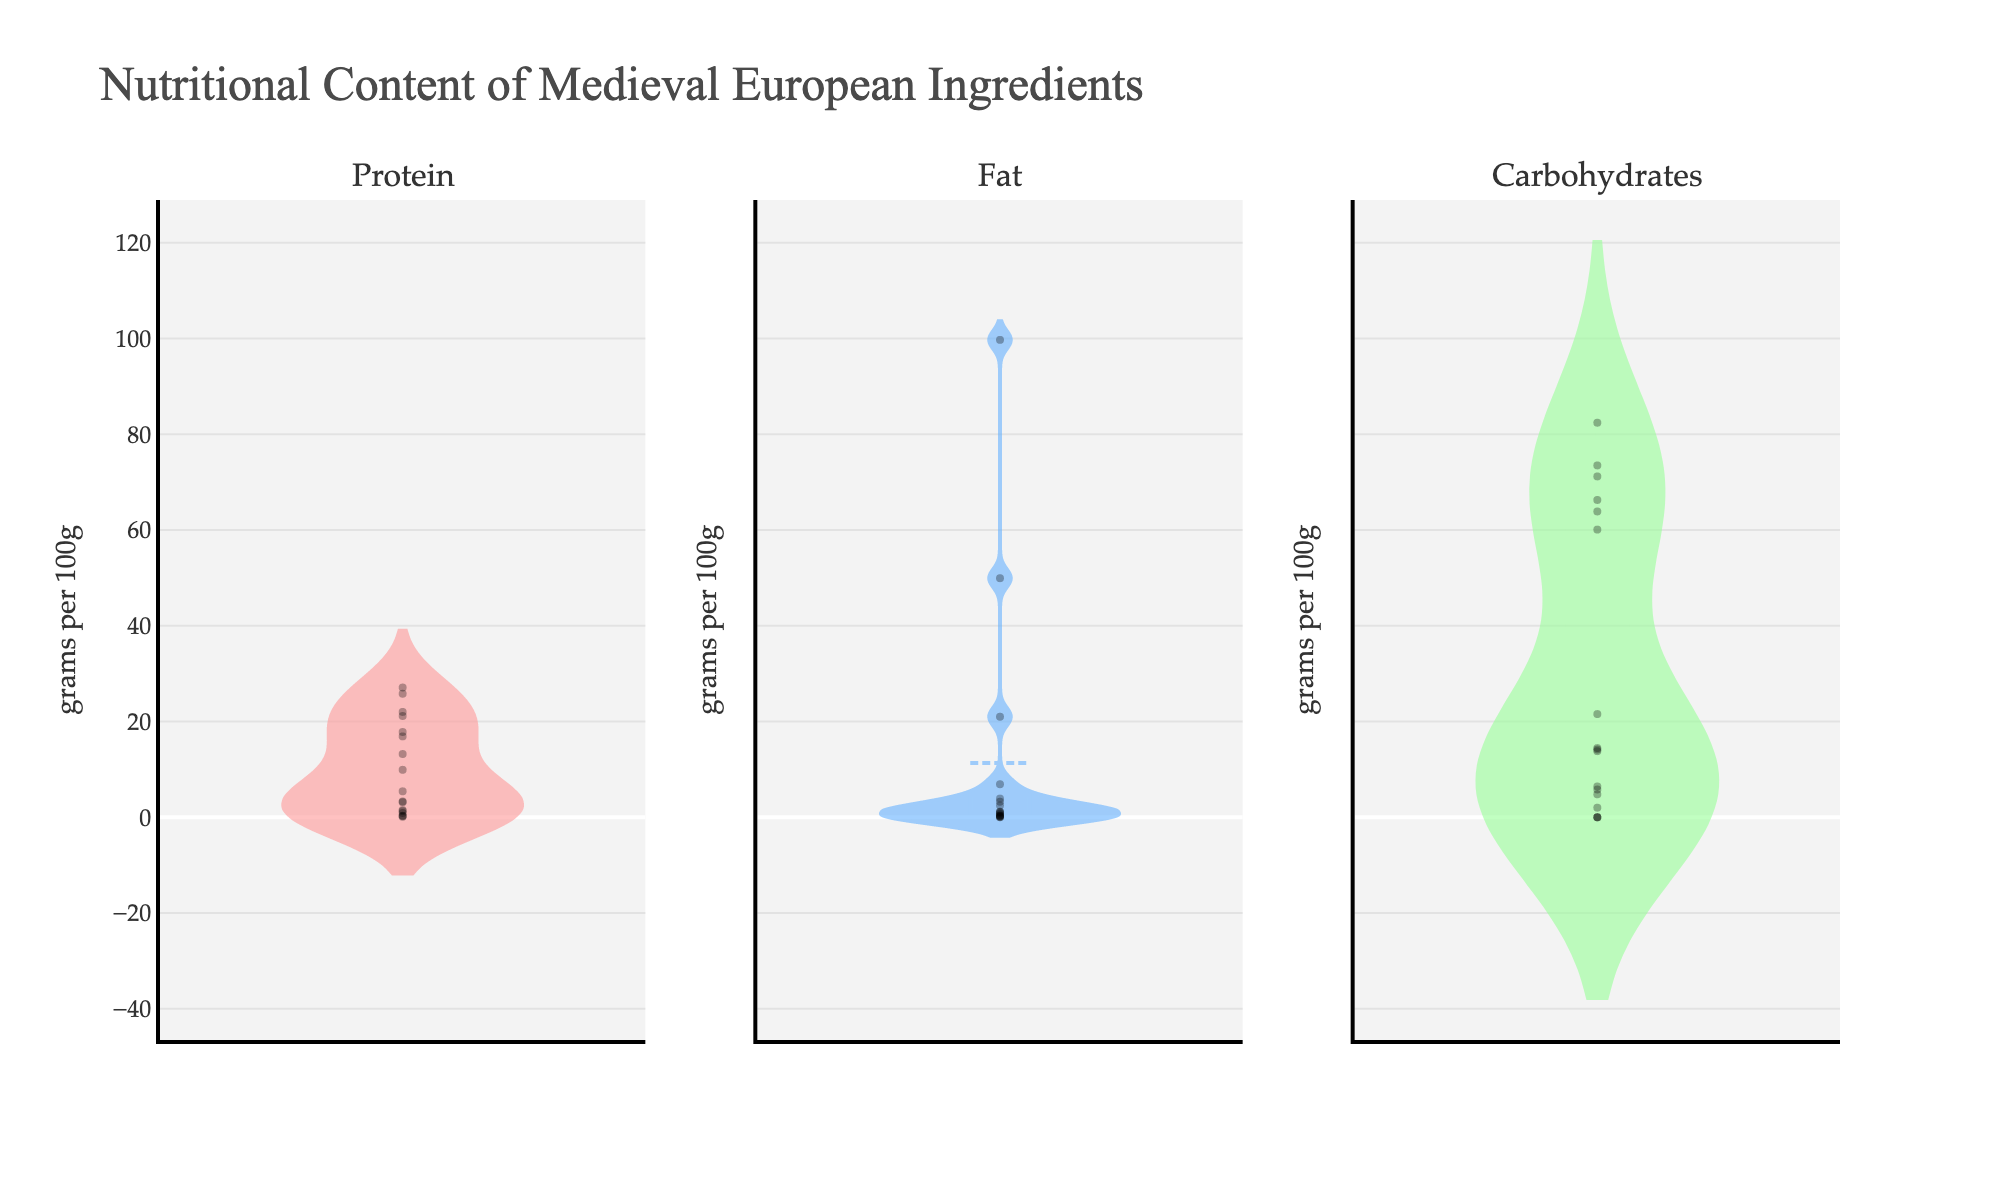What is the title of the plot? The title of the plot can be found at the top and typically provides a brief description of what the figure represents. In this case, it is "Nutritional Content of Medieval European Ingredients".
Answer: Nutritional Content of Medieval European Ingredients Which ingredient has the highest amount of fat per 100g? By observing the violin plot for fat distribution, we can identify the ingredient with the highest value. The pork fat ingredient's data point is noticeably higher than all others.
Answer: Pork Fat What is the median value of carbohydrates? To find the median value, we look for the horizontal line inside the box plot overlay on the violin chart for carbohydrates. The median can be visually identified from this line.
Answer: 21.55 g/100g Which macro-nutrient category shows the greatest spread? By comparing the width and overall shape of the violin plots for protein, fat, and carbohydrates, the category with the widest distribution has the greatest spread. Carbohydrates show significant spread across a wider range of values.
Answer: Carbohydrates How does the maximum value of protein compare to the maximum value of carbohydrates? Identify the peaks of the violin plots for both protein and carbohydrates. The highest point in protein is 27.10 g/100g (Goat Meat), while the highest point in carbohydrates is 82.40 g/100g (Honey).
Answer: Carbohydrates are higher Is the average fat content higher or lower than the average protein content? Average values can be inferred by observing the plots' central tendencies (mean lines inside the box plots). Fat average seems higher due to the presence of Pork Fat and Almonds.
Answer: Higher Are any ingredients free of carbohydrates? We need to see if any violin plot section for carbohydrates contains a data point at 0 g/100g. Ingredients like goat meat, fish (cod), and pork fat might exhibit this characteristic.
Answer: Yes Which ingredient has the smallest amount of protein per 100g? The minimum value can be found at the low end of the protein violin plot axis, represented by the smallest observed data point.
Answer: Honey Which nutrient shows the highest concentration for a single ingredient, and what is that value? Look at all violin plots to determine the highest single value point among all nutrients. Carbohydrates in honey (82.40 g) are the largest.
Answer: Carbohydrates, 82.40 g/100g (Honey) 